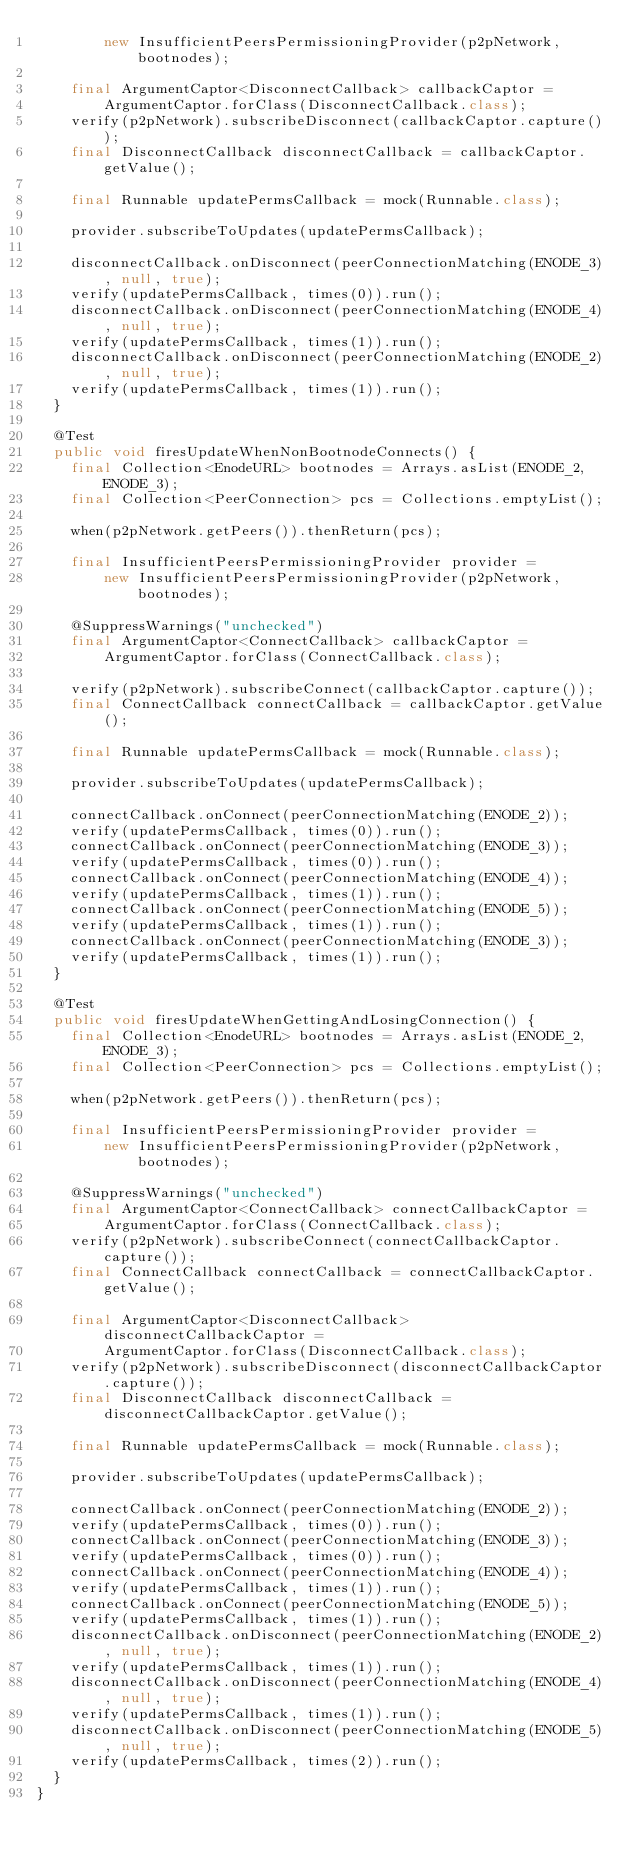<code> <loc_0><loc_0><loc_500><loc_500><_Java_>        new InsufficientPeersPermissioningProvider(p2pNetwork, bootnodes);

    final ArgumentCaptor<DisconnectCallback> callbackCaptor =
        ArgumentCaptor.forClass(DisconnectCallback.class);
    verify(p2pNetwork).subscribeDisconnect(callbackCaptor.capture());
    final DisconnectCallback disconnectCallback = callbackCaptor.getValue();

    final Runnable updatePermsCallback = mock(Runnable.class);

    provider.subscribeToUpdates(updatePermsCallback);

    disconnectCallback.onDisconnect(peerConnectionMatching(ENODE_3), null, true);
    verify(updatePermsCallback, times(0)).run();
    disconnectCallback.onDisconnect(peerConnectionMatching(ENODE_4), null, true);
    verify(updatePermsCallback, times(1)).run();
    disconnectCallback.onDisconnect(peerConnectionMatching(ENODE_2), null, true);
    verify(updatePermsCallback, times(1)).run();
  }

  @Test
  public void firesUpdateWhenNonBootnodeConnects() {
    final Collection<EnodeURL> bootnodes = Arrays.asList(ENODE_2, ENODE_3);
    final Collection<PeerConnection> pcs = Collections.emptyList();

    when(p2pNetwork.getPeers()).thenReturn(pcs);

    final InsufficientPeersPermissioningProvider provider =
        new InsufficientPeersPermissioningProvider(p2pNetwork, bootnodes);

    @SuppressWarnings("unchecked")
    final ArgumentCaptor<ConnectCallback> callbackCaptor =
        ArgumentCaptor.forClass(ConnectCallback.class);

    verify(p2pNetwork).subscribeConnect(callbackCaptor.capture());
    final ConnectCallback connectCallback = callbackCaptor.getValue();

    final Runnable updatePermsCallback = mock(Runnable.class);

    provider.subscribeToUpdates(updatePermsCallback);

    connectCallback.onConnect(peerConnectionMatching(ENODE_2));
    verify(updatePermsCallback, times(0)).run();
    connectCallback.onConnect(peerConnectionMatching(ENODE_3));
    verify(updatePermsCallback, times(0)).run();
    connectCallback.onConnect(peerConnectionMatching(ENODE_4));
    verify(updatePermsCallback, times(1)).run();
    connectCallback.onConnect(peerConnectionMatching(ENODE_5));
    verify(updatePermsCallback, times(1)).run();
    connectCallback.onConnect(peerConnectionMatching(ENODE_3));
    verify(updatePermsCallback, times(1)).run();
  }

  @Test
  public void firesUpdateWhenGettingAndLosingConnection() {
    final Collection<EnodeURL> bootnodes = Arrays.asList(ENODE_2, ENODE_3);
    final Collection<PeerConnection> pcs = Collections.emptyList();

    when(p2pNetwork.getPeers()).thenReturn(pcs);

    final InsufficientPeersPermissioningProvider provider =
        new InsufficientPeersPermissioningProvider(p2pNetwork, bootnodes);

    @SuppressWarnings("unchecked")
    final ArgumentCaptor<ConnectCallback> connectCallbackCaptor =
        ArgumentCaptor.forClass(ConnectCallback.class);
    verify(p2pNetwork).subscribeConnect(connectCallbackCaptor.capture());
    final ConnectCallback connectCallback = connectCallbackCaptor.getValue();

    final ArgumentCaptor<DisconnectCallback> disconnectCallbackCaptor =
        ArgumentCaptor.forClass(DisconnectCallback.class);
    verify(p2pNetwork).subscribeDisconnect(disconnectCallbackCaptor.capture());
    final DisconnectCallback disconnectCallback = disconnectCallbackCaptor.getValue();

    final Runnable updatePermsCallback = mock(Runnable.class);

    provider.subscribeToUpdates(updatePermsCallback);

    connectCallback.onConnect(peerConnectionMatching(ENODE_2));
    verify(updatePermsCallback, times(0)).run();
    connectCallback.onConnect(peerConnectionMatching(ENODE_3));
    verify(updatePermsCallback, times(0)).run();
    connectCallback.onConnect(peerConnectionMatching(ENODE_4));
    verify(updatePermsCallback, times(1)).run();
    connectCallback.onConnect(peerConnectionMatching(ENODE_5));
    verify(updatePermsCallback, times(1)).run();
    disconnectCallback.onDisconnect(peerConnectionMatching(ENODE_2), null, true);
    verify(updatePermsCallback, times(1)).run();
    disconnectCallback.onDisconnect(peerConnectionMatching(ENODE_4), null, true);
    verify(updatePermsCallback, times(1)).run();
    disconnectCallback.onDisconnect(peerConnectionMatching(ENODE_5), null, true);
    verify(updatePermsCallback, times(2)).run();
  }
}
</code> 